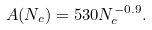Convert formula to latex. <formula><loc_0><loc_0><loc_500><loc_500>A ( N _ { c } ) = 5 3 0 N _ { c } ^ { - 0 . 9 } .</formula> 